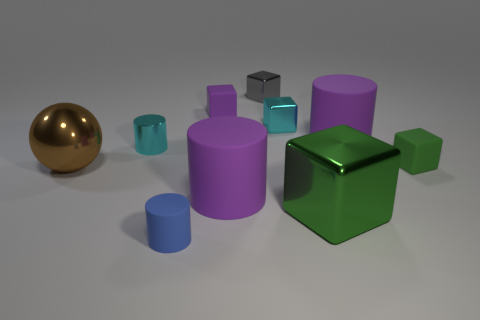Subtract all small cyan cubes. How many cubes are left? 4 Subtract all cylinders. How many objects are left? 6 Subtract 4 cylinders. How many cylinders are left? 0 Subtract 0 red balls. How many objects are left? 10 Subtract all cyan balls. Subtract all green cylinders. How many balls are left? 1 Subtract all gray cubes. How many blue cylinders are left? 1 Subtract all small blue objects. Subtract all rubber cylinders. How many objects are left? 6 Add 5 tiny green matte blocks. How many tiny green matte blocks are left? 6 Add 4 small blue rubber things. How many small blue rubber things exist? 5 Subtract all gray blocks. How many blocks are left? 4 